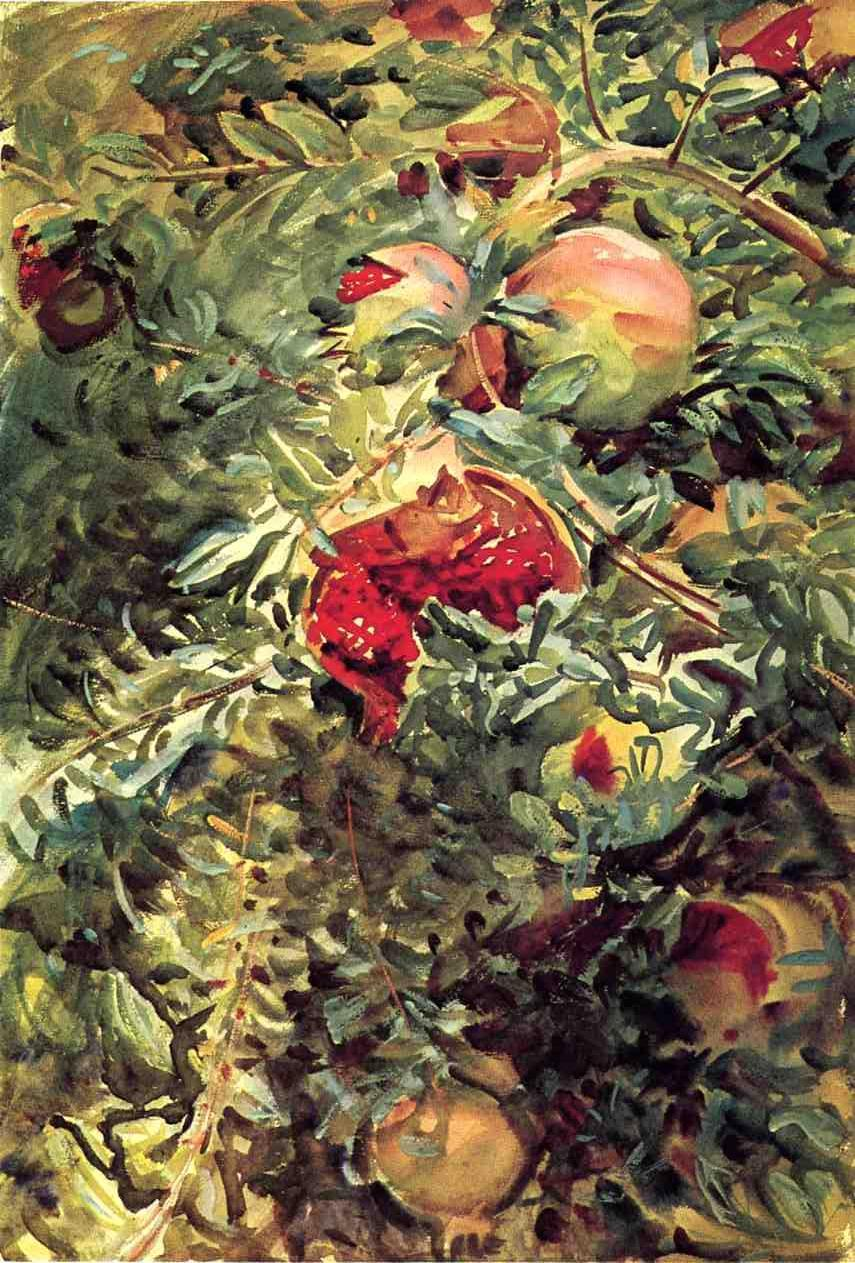Can you describe the mood or atmosphere that this painting might evoke? The artwork evokes a vibrant and energetic atmosphere, likely meant to celebrate the beauty and bounty of nature. The interplay of light and the rich, warm colors contribute to a feeling of abundance and vitality, while the dynamic, almost chaotic brushstrokes may impart a sense of life's fleeting, ever-changing moments. 